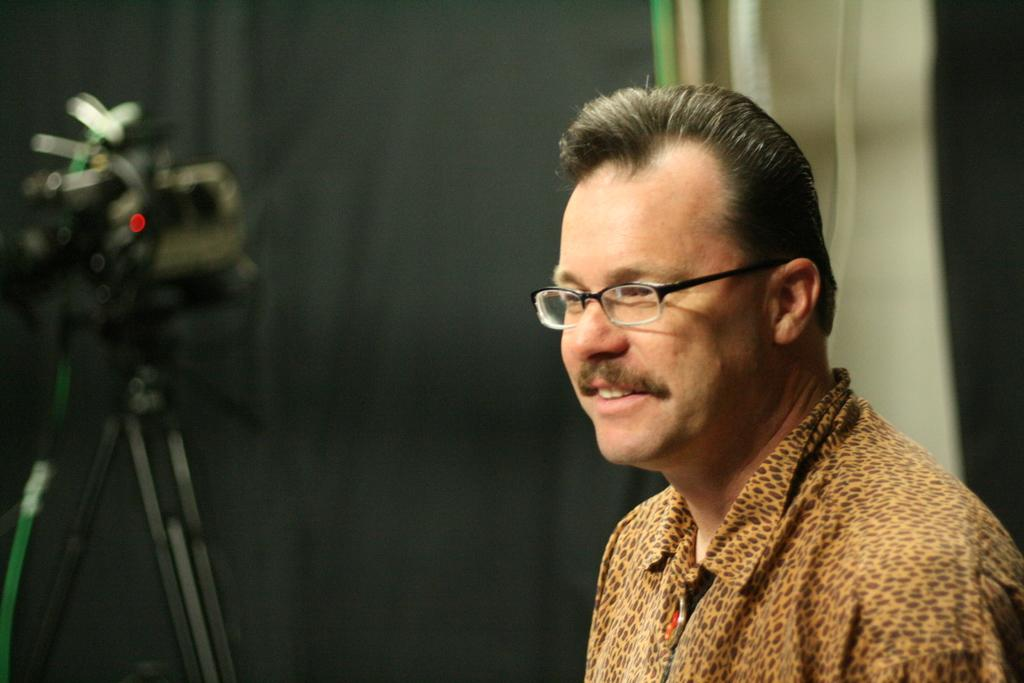Who is present in the image? There is a man in the image. What is the man wearing on his upper body? The man is wearing an animal-printed shirt. What accessory is the man wearing on his face? The man is wearing spectacles. How is the background of the image depicted? The background of the man is blurred. What type of cracker is the man holding in the image? There is no cracker present in the image. What arithmetic problem is the man solving in the image? There is no arithmetic problem depicted in the image. 